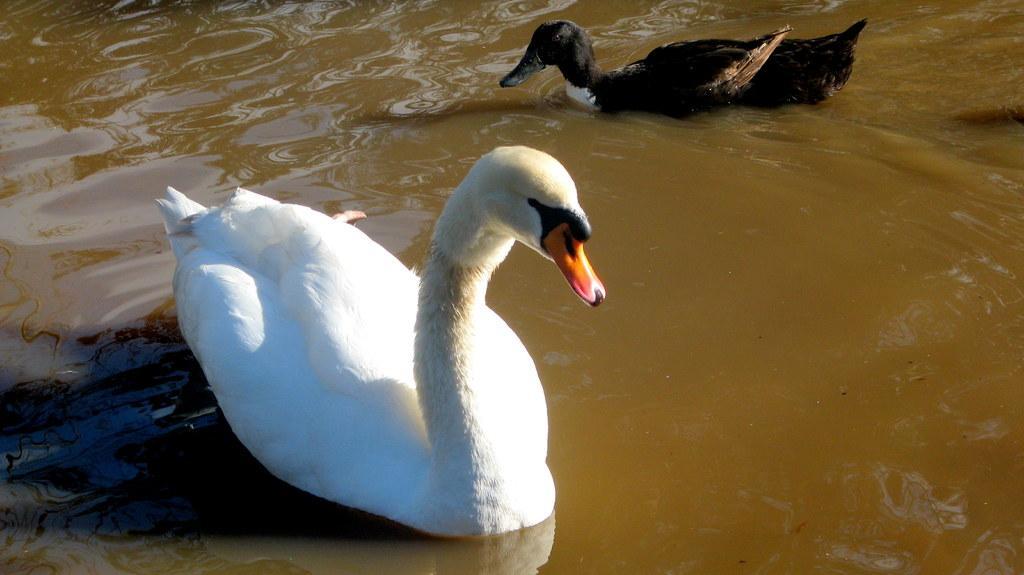Can you describe this image briefly? In this image, we can see some swans in the water. 